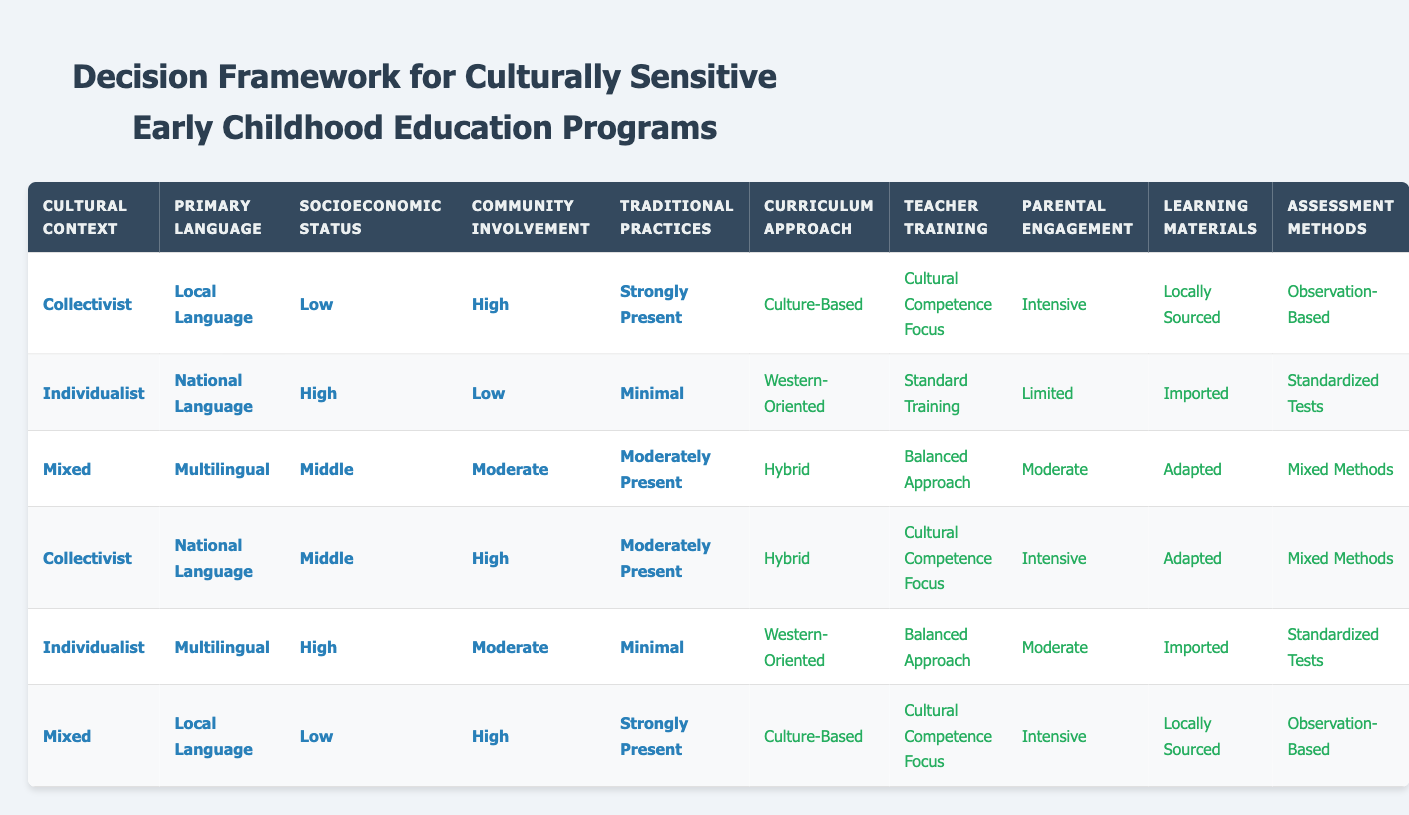What is the Curriculum Approach for a Collectivist community with a Local Language, Low socioeconomic status, High Community Involvement, and Strongly Present Traditional Practices? In the table, we locate the row with the specified conditions: Collectivist, Local Language, Low, High, Strongly Present. In that row, the Curriculum Approach is listed as "Culture-Based."
Answer: Culture-Based How many different Curriculum Approaches are represented in the table? The table lists three unique Curriculum Approaches: Culture-Based, Hybrid, and Western-Oriented. Therefore, the count is 3.
Answer: 3 Is there a case where the Teacher Training option is Standard Training? Looking through the table, the only row that lists Standard Training for Teacher Training is in the condition with Individualist, National Language, High, Low, and Minimal Traditional Practices. Hence, the answer is yes.
Answer: Yes What is the Parental Engagement level when the conditions are Mixed, Multilingual, Middle, Moderate, and Moderately Present? By checking the relevant row for the conditions provided, we find that Parental Engagement at this condition lists "Moderate."
Answer: Moderate For the row with Individualist, Multilingual, High, Moderate, and Minimal Traditional Practices, what are the Learning Materials used? We examine the associated row in the table that corresponds with these conditions, where the Learning Materials are described as "Imported.”
Answer: Imported Based on the information in the table, which condition has the highest frequency of intensive parental engagement? Evaluating the rows, we note that the conditions Collectivist, Local Language, Low, High, Strongly Present, and Collectivist, National Language, Middle, High, Moderately Present both have "Intensive" for Parental Engagement. Thus, "Collectivist" conditions show the highest frequency.
Answer: Collectivist Which socioeconomic status has the most diverse assessment methods according to the table? Assessing the data, items under Low socioeconomic status have two different assessment methods (Observation-Based). Middle socioeconomic status offers Mixed Methods, while High shows Standardized Tests and Limited variance. Thus, Middle has the most diversity with three unique methods.
Answer: Middle What is the relationship between Community Involvement and Assessment Methods in high Socioeconomic status? In examining the rows where Socioeconomic Status is High, we see that community involvement varies as Low and Moderate. The corresponding assessment methods are Standardized Tests (Low) and Mixed Methods (Moderate). Therefore, the relationship shows higher assessment diversity with Moderate Community Involvement.
Answer: Higher assessment diversity with Moderate Community Involvement 